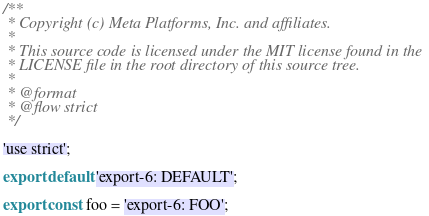<code> <loc_0><loc_0><loc_500><loc_500><_JavaScript_>/**
 * Copyright (c) Meta Platforms, Inc. and affiliates.
 *
 * This source code is licensed under the MIT license found in the
 * LICENSE file in the root directory of this source tree.
 *
 * @format
 * @flow strict
 */

'use strict';

export default 'export-6: DEFAULT';

export const foo = 'export-6: FOO';
</code> 